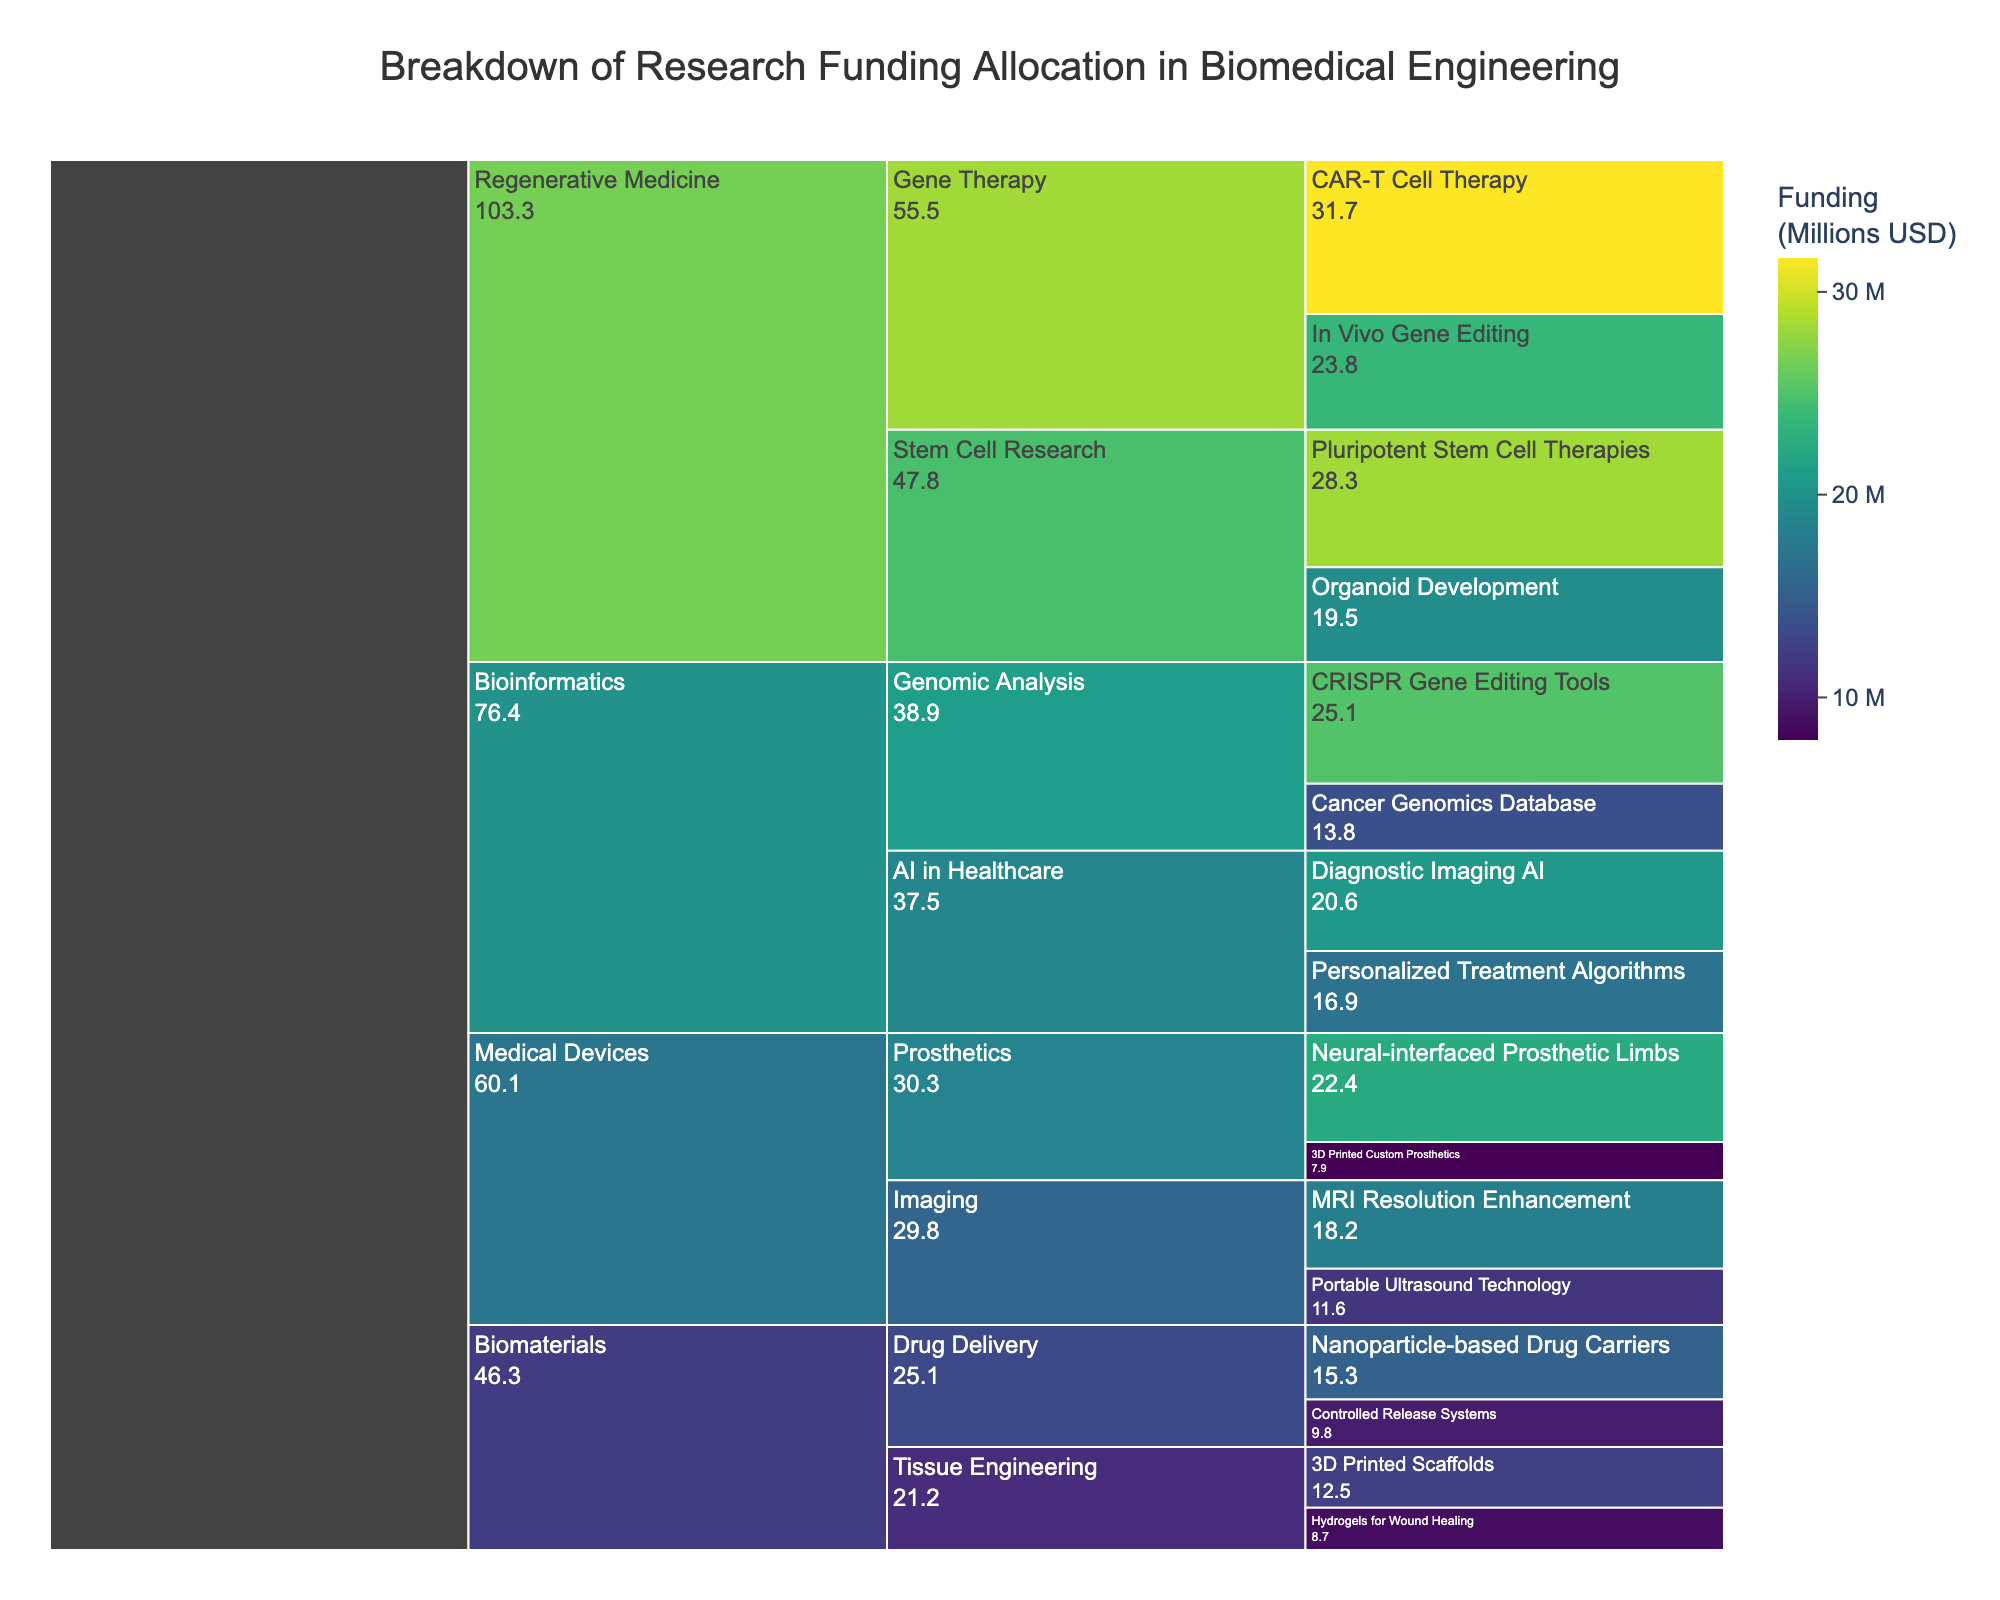What is the total funding allocated to the Regenerative Medicine category? To calculate the total funding for Regenerative Medicine, sum the funding amounts of its subcategories. This includes Pluripotent Stem Cell Therapies ($28.3M), Organoid Development ($19.5M), CAR-T Cell Therapy ($31.7M), and In Vivo Gene Editing ($23.8M). The total is $28.3M + $19.5M + $31.7M + $23.8M = $103.3M.
Answer: $103.3M Which project received the highest funding in the Biomedical Engineering breakdown? To find the project with the highest funding, compare the funding values for each project. The highest value is for CAR-T Cell Therapy in the Gene Therapy subcategory of Regenerative Medicine at $31.7M.
Answer: CAR-T Cell Therapy What is the difference in funding between the Imaging subcategory and the Prosthetics subcategory within Medical Devices? First, sum up the funding in the Imaging subcategory (MRI Resolution Enhancement ($18.2M) + Portable Ultrasound Technology ($11.6M) = $29.8M). Then, sum up the funding in Prosthetics (Neural-interfaced Prosthetic Limbs ($22.4M) + 3D Printed Custom Prosthetics ($7.9M) = $30.3M). The difference is $30.3M - $29.8M = $0.5M.
Answer: $0.5M Which subcategory in the Bioinformatics category has the smallest total funding? To determine the subcategory with the smallest total funding in Bioinformatics, sum the funding amounts in each subcategory and compare them. CRISPR Gene Editing Tools and Cancer Genomics Database have $25.1M + $13.8M = $38.9M, while Diagnostic Imaging AI and Personalized Treatment Algorithms have $20.6M + $16.9M = $37.5M. Therefore, AI in Healthcare has the smallest total funding at $37.5M.
Answer: AI in Healthcare How much more funding does Gene Therapy receive than Tissue Engineering in the Biomaterials category? Calculate the total funding for Gene Therapy ($31.7M + $23.8M = $55.5M) and Tissue Engineering ($12.5M + $8.7M = $21.2M). The difference is $55.5M - $21.2M = $34.3M.
Answer: $34.3M What is the total funding allocation for all Bioinformatics projects combined? Sum the funding for all Bioinformatics projects: CRISPR Gene Editing Tools ($25.1M), Cancer Genomics Database ($13.8M), Diagnostic Imaging AI ($20.6M), and Personalized Treatment Algorithms ($16.9M). The total is $25.1M + $13.8M + $20.6M + $16.9M = $76.4M.
Answer: $76.4M Which category has the least total funding, and what is its amount? Sum the funding for each category and compare them. Biomaterials: $12.5M + $8.7M + $15.3M + $9.8M = $46.3M; Medical Devices: $18.2M + $11.6M + $22.4M + $7.9M = $60.1M; Bioinformatics: $76.4M; Regenerative Medicine: $103.3M. The category with the least funding is Biomaterials at $46.3M.
Answer: Biomaterials, $46.3M What percentage of the total funding does the CRISPR Gene Editing Tools project receive? Find the total funding for all projects, sum of all funding amounts: $491.9M. To find the percentage, divide the funding for CRISPR Gene Editing Tools by the total funding and multiply by 100: ($25.1M / $491.9M) * 100 = 5.1%.
Answer: 5.1% 